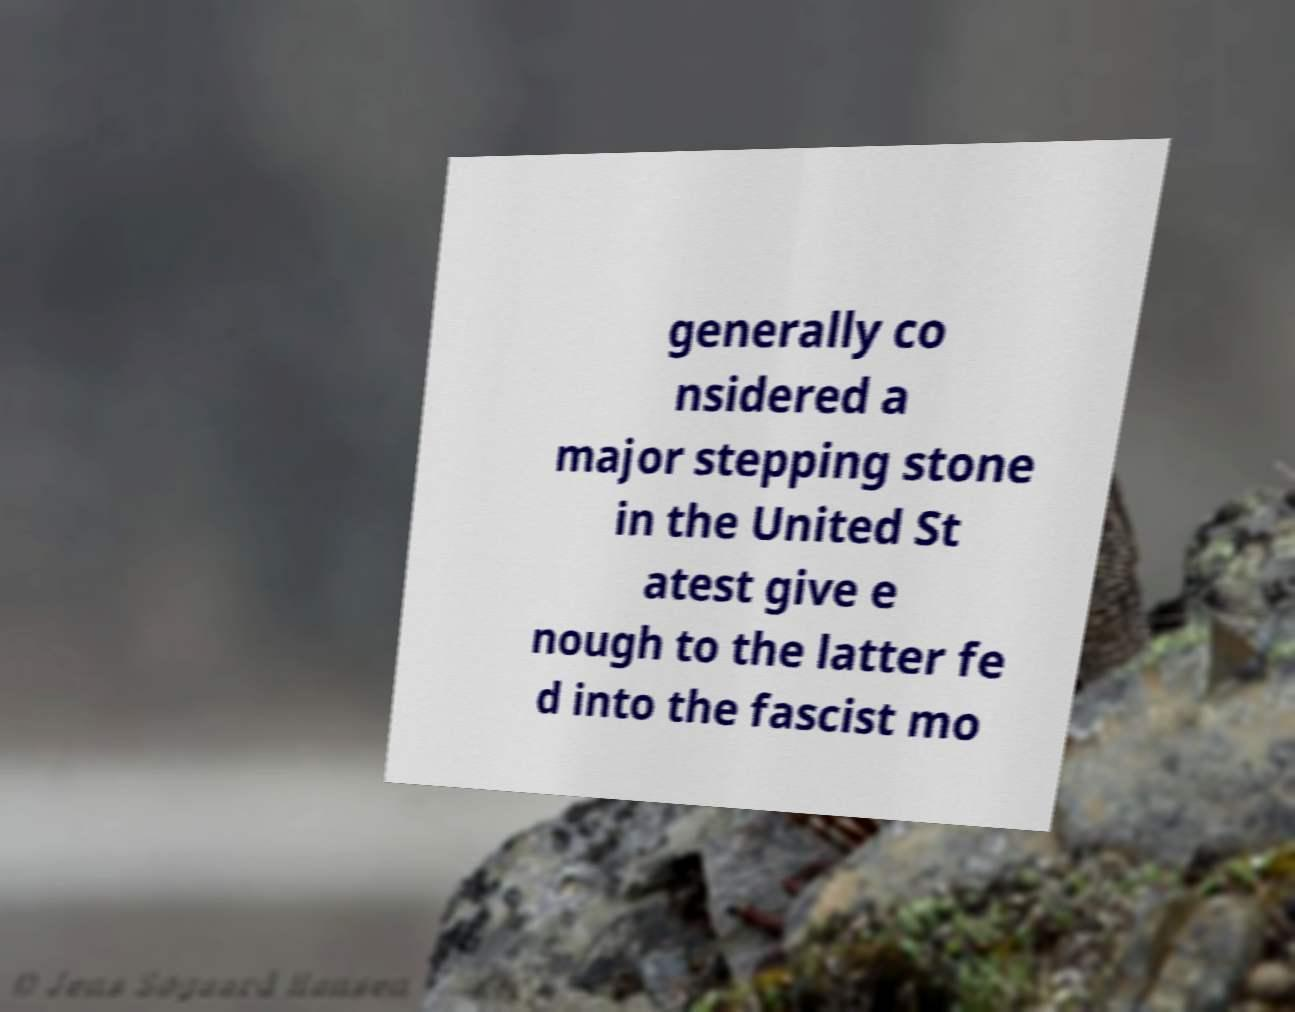Can you accurately transcribe the text from the provided image for me? generally co nsidered a major stepping stone in the United St atest give e nough to the latter fe d into the fascist mo 